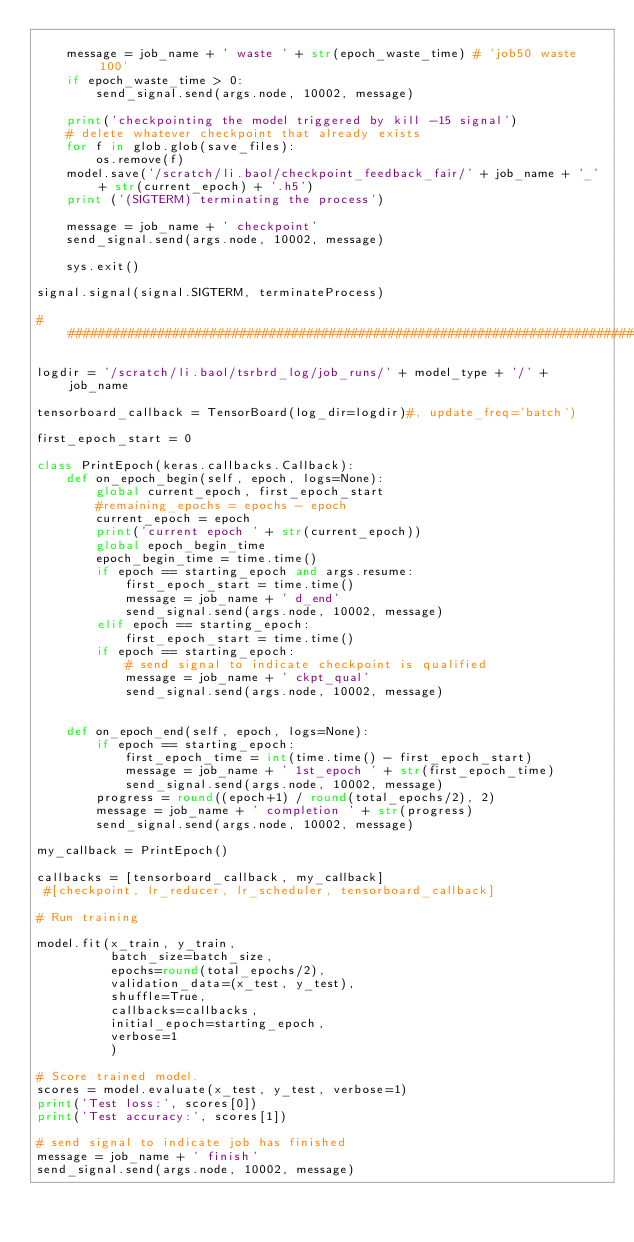<code> <loc_0><loc_0><loc_500><loc_500><_Python_>
    message = job_name + ' waste ' + str(epoch_waste_time) # 'job50 waste 100'
    if epoch_waste_time > 0:
        send_signal.send(args.node, 10002, message)

    print('checkpointing the model triggered by kill -15 signal')
    # delete whatever checkpoint that already exists
    for f in glob.glob(save_files):
        os.remove(f)
    model.save('/scratch/li.baol/checkpoint_feedback_fair/' + job_name + '_' + str(current_epoch) + '.h5')
    print ('(SIGTERM) terminating the process')

    message = job_name + ' checkpoint'
    send_signal.send(args.node, 10002, message)

    sys.exit()

signal.signal(signal.SIGTERM, terminateProcess)

#################################################################################

logdir = '/scratch/li.baol/tsrbrd_log/job_runs/' + model_type + '/' + job_name

tensorboard_callback = TensorBoard(log_dir=logdir)#, update_freq='batch')

first_epoch_start = 0

class PrintEpoch(keras.callbacks.Callback):
    def on_epoch_begin(self, epoch, logs=None):
        global current_epoch, first_epoch_start
        #remaining_epochs = epochs - epoch
        current_epoch = epoch
        print('current epoch ' + str(current_epoch))
        global epoch_begin_time
        epoch_begin_time = time.time()
        if epoch == starting_epoch and args.resume:
            first_epoch_start = time.time()
            message = job_name + ' d_end'
            send_signal.send(args.node, 10002, message)
        elif epoch == starting_epoch:
            first_epoch_start = time.time()           
        if epoch == starting_epoch:
            # send signal to indicate checkpoint is qualified
            message = job_name + ' ckpt_qual'
            send_signal.send(args.node, 10002, message)


    def on_epoch_end(self, epoch, logs=None):
        if epoch == starting_epoch:
            first_epoch_time = int(time.time() - first_epoch_start)
            message = job_name + ' 1st_epoch ' + str(first_epoch_time)
            send_signal.send(args.node, 10002, message)
        progress = round((epoch+1) / round(total_epochs/2), 2)
        message = job_name + ' completion ' + str(progress)
        send_signal.send(args.node, 10002, message)

my_callback = PrintEpoch()

callbacks = [tensorboard_callback, my_callback]
 #[checkpoint, lr_reducer, lr_scheduler, tensorboard_callback]

# Run training

model.fit(x_train, y_train,
          batch_size=batch_size,
          epochs=round(total_epochs/2),
          validation_data=(x_test, y_test),
          shuffle=True,
          callbacks=callbacks,
          initial_epoch=starting_epoch,
          verbose=1
          )

# Score trained model.
scores = model.evaluate(x_test, y_test, verbose=1)
print('Test loss:', scores[0])
print('Test accuracy:', scores[1])

# send signal to indicate job has finished
message = job_name + ' finish'
send_signal.send(args.node, 10002, message)
</code> 